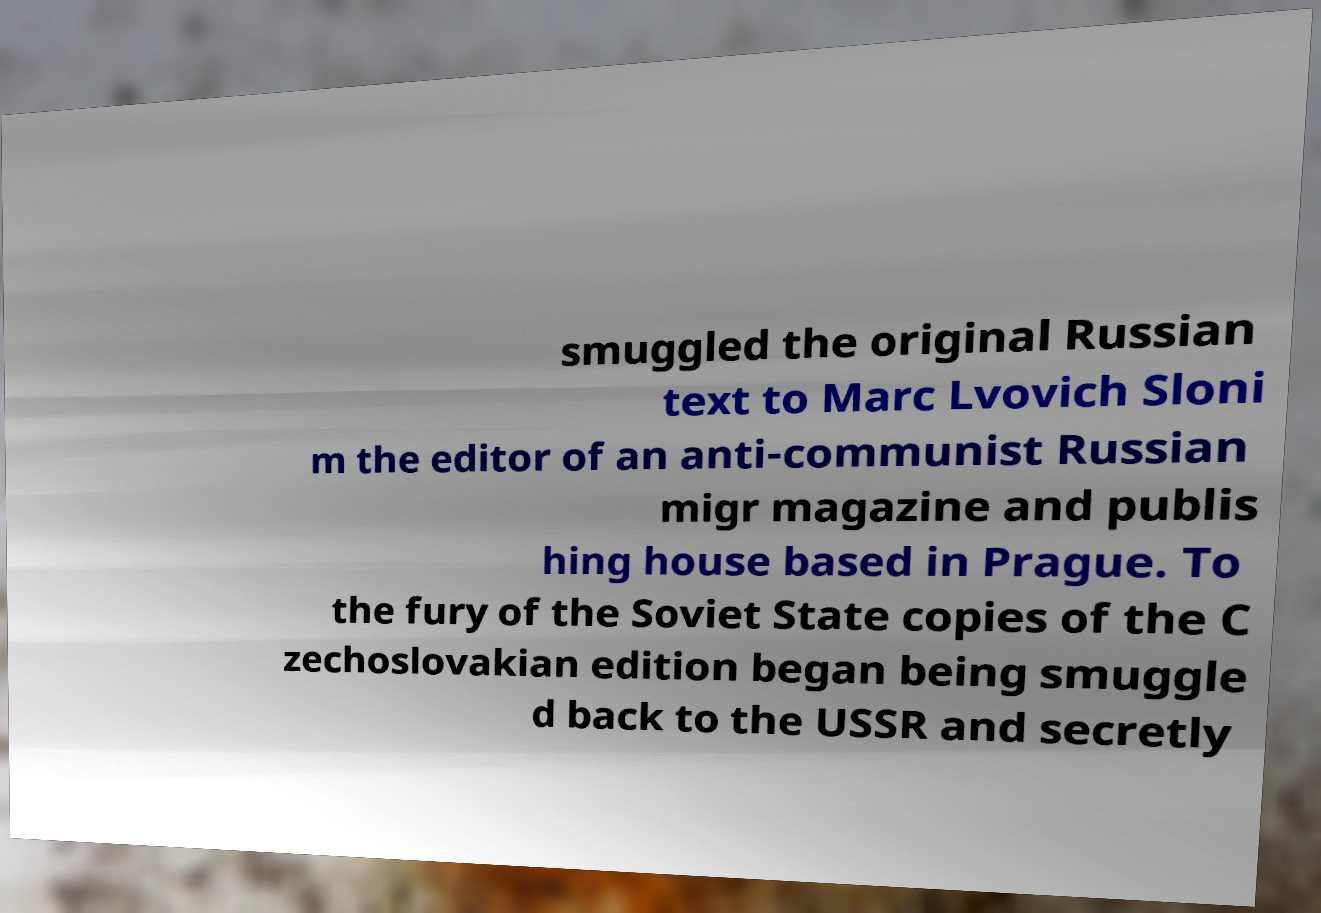I need the written content from this picture converted into text. Can you do that? smuggled the original Russian text to Marc Lvovich Sloni m the editor of an anti-communist Russian migr magazine and publis hing house based in Prague. To the fury of the Soviet State copies of the C zechoslovakian edition began being smuggle d back to the USSR and secretly 